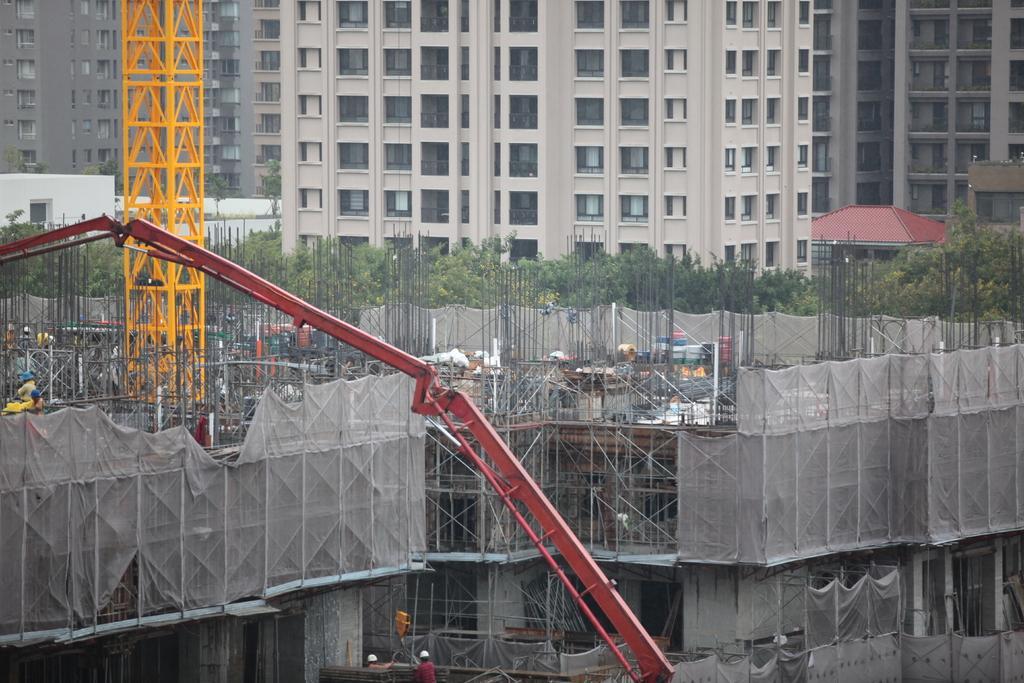Can you describe this image briefly? In this picture we can see construction of a building, cranes, rods and some people wore helmets. In the background we can see trees and buildings with windows. 